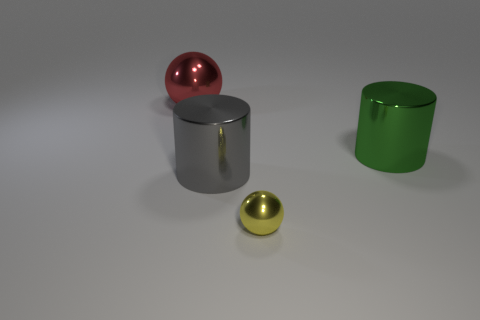There is a ball that is on the left side of the sphere that is right of the large red metal thing; what is its color?
Your answer should be compact. Red. What size is the sphere that is right of the large metallic ball behind the shiny ball that is on the right side of the red metallic thing?
Ensure brevity in your answer.  Small. Are there fewer big red spheres that are in front of the tiny sphere than large green things that are behind the green thing?
Your response must be concise. No. What number of tiny objects have the same material as the tiny yellow sphere?
Your answer should be compact. 0. There is a shiny cylinder that is on the right side of the ball that is in front of the large ball; are there any large objects that are right of it?
Your answer should be very brief. No. There is a green object that is the same material as the large gray cylinder; what is its shape?
Offer a terse response. Cylinder. Are there more gray metallic cylinders than big metallic cylinders?
Provide a succinct answer. No. Do the red metal object and the small yellow thing that is on the left side of the big green cylinder have the same shape?
Provide a succinct answer. Yes. What is the large red ball made of?
Provide a short and direct response. Metal. What is the color of the big shiny object that is behind the large cylinder behind the cylinder in front of the green shiny thing?
Your answer should be compact. Red. 